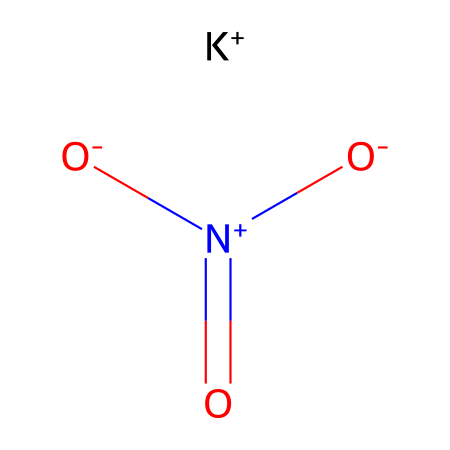What is the name of this chemical? The given SMILES representation corresponds to potassium nitrate, which is a well-known inorganic compound used as a fertilizer. This can be determined by recognizing the potassium (K) and nitrate ion (NO3) present in the structure.
Answer: potassium nitrate How many oxygen atoms are present in this compound? By analyzing the SMILES representation, we see that the nitrate ion consists of three oxygen atoms bonded to the nitrogen atom. Therefore, the total count of oxygen atoms in potassium nitrate is three.
Answer: three What is the oxidation state of nitrogen in potassium nitrate? In the SMILES, nitrogen is part of the nitrate group (NO3). In this context, the oxidation state of nitrogen can be calculated as +5, since nitrogen in nitrate is typically +5 in its most common state.
Answer: five How many total ions are in the compound represented? The SMILES notation indicates the presence of two ions: potassium ion (K+) and the nitrate ion (NO3-) which consists of one nitrogen and three oxygens. Therefore, we have a total of two ions in the compound.
Answer: two What type of bond connects potassium to the nitrate ion? The connection between the potassium ion (K+) and the nitrate ion (NO3-) involves an ionic bond, as potassium has a positive charge which attracts the negatively charged nitrate ion. This is characteristic of salts such as potassium nitrate.
Answer: ionic Is potassium nitrate soluble in water? Potassium nitrate is highly soluble in water, which is a common property of inorganic salts. This can be inferred from its ionic character, allowing it to dissociate completely in water.
Answer: yes What is the function of potassium nitrate when used in gardening? As a fertilizer, potassium nitrate provides essential nutrients: potassium, which is vital for plant growth and development, and nitrogen, which supports leafy growth. This dual nutrient supply makes it beneficial in gardening.
Answer: fertilizer 